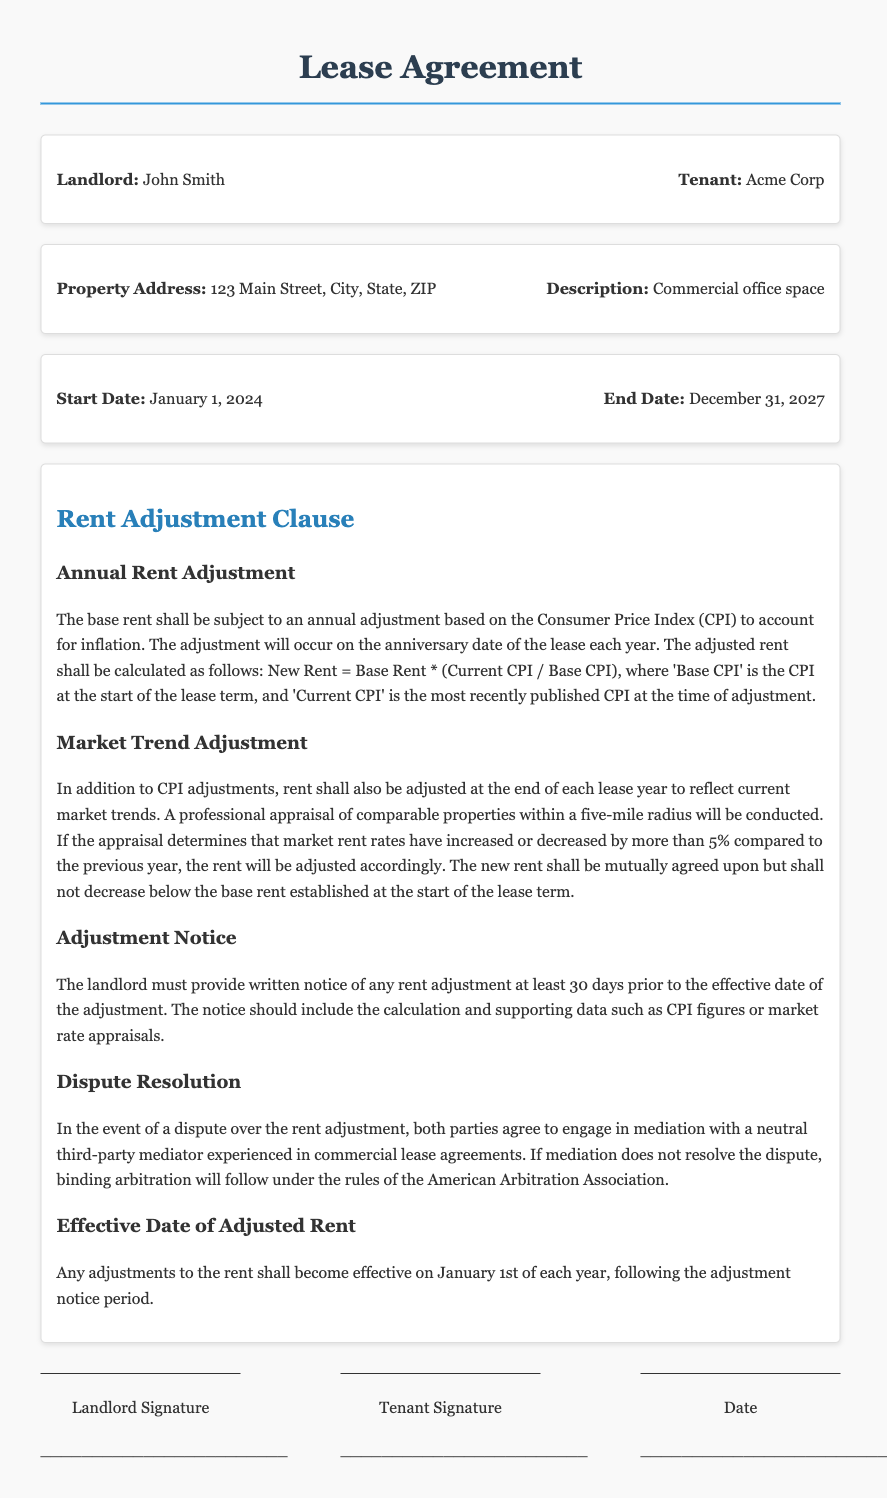What is the landlord's name? The landlord's name is stated in the document as John Smith.
Answer: John Smith What is the property address? The property address is listed in the document as 123 Main Street, City, State, ZIP.
Answer: 123 Main Street, City, State, ZIP What is the start date of the lease? The document specifies that the lease starts on January 1, 2024.
Answer: January 1, 2024 How is the new rent calculated? The document indicates the formula for new rent is New Rent = Base Rent * (Current CPI / Base CPI).
Answer: New Rent = Base Rent * (Current CPI / Base CPI) What is the minimum rent adjustment? The lease agreement states that rent will not decrease below the base rent established at the start of the lease term.
Answer: Base rent What is the notice period for a rent adjustment? The document specifies that the landlord must provide written notice at least 30 days prior to any rent adjustment.
Answer: 30 days What type of dispute resolution is specified? According to the document, both parties agree to engage in mediation followed by binding arbitration if necessary.
Answer: Mediation and arbitration When do rent adjustments become effective? The document states that any adjustments to the rent become effective on January 1st of each year.
Answer: January 1st What is the adjustment basis for rent besides CPI? The document mentions that rent shall also be adjusted based on current market trends assessed through a professional appraisal.
Answer: Market trends 